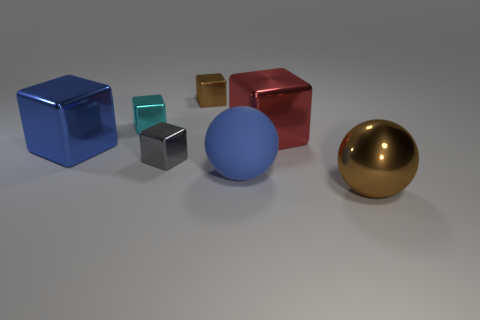Subtract all cyan metallic blocks. How many blocks are left? 4 Add 1 big metal blocks. How many objects exist? 8 Subtract all blue spheres. How many spheres are left? 1 Subtract all blocks. How many objects are left? 2 Subtract all tiny cyan shiny things. Subtract all big purple rubber spheres. How many objects are left? 6 Add 3 metal blocks. How many metal blocks are left? 8 Add 5 tiny gray shiny blocks. How many tiny gray shiny blocks exist? 6 Subtract 0 red cylinders. How many objects are left? 7 Subtract 1 balls. How many balls are left? 1 Subtract all blue spheres. Subtract all gray cylinders. How many spheres are left? 1 